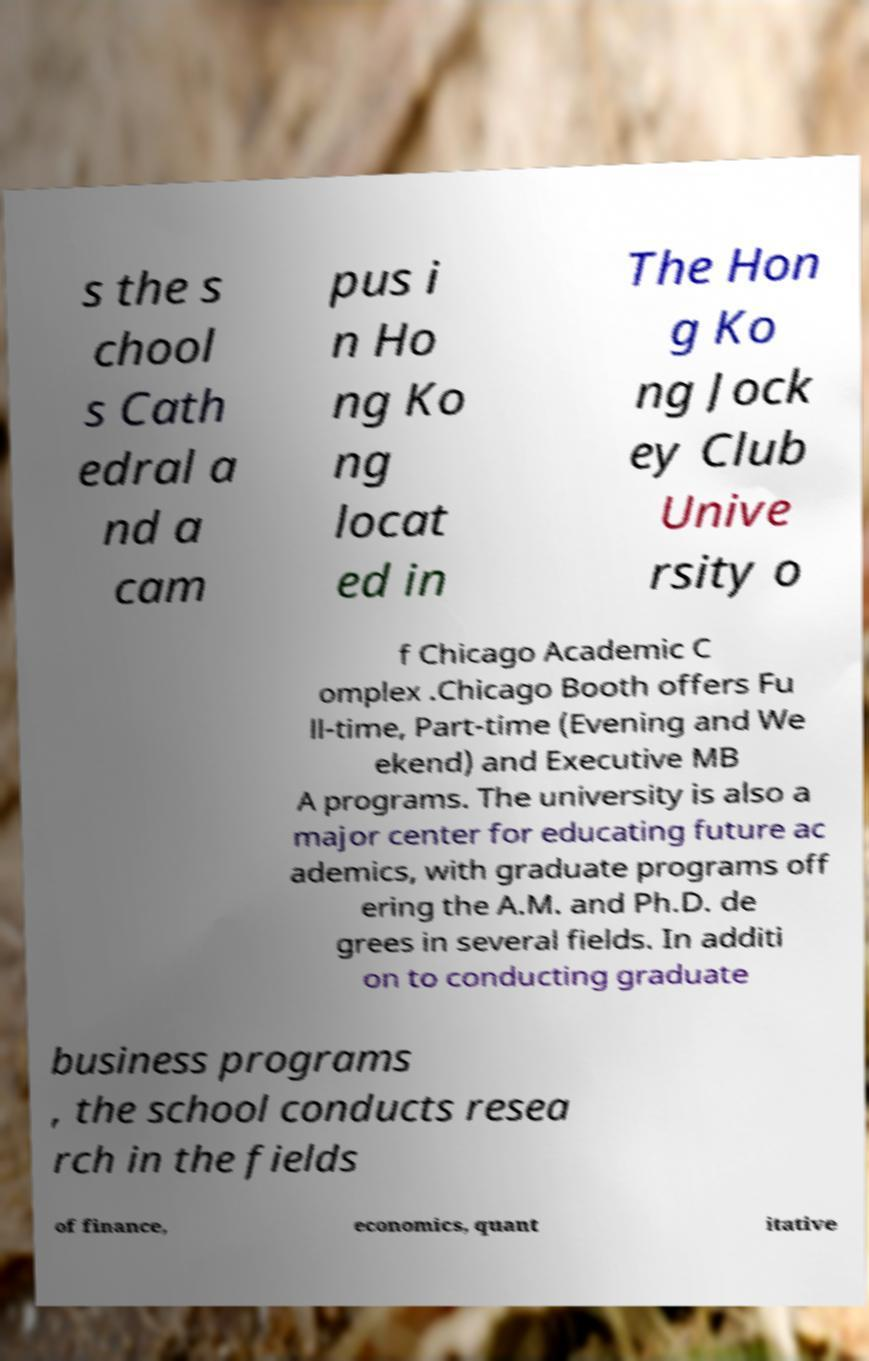Could you assist in decoding the text presented in this image and type it out clearly? s the s chool s Cath edral a nd a cam pus i n Ho ng Ko ng locat ed in The Hon g Ko ng Jock ey Club Unive rsity o f Chicago Academic C omplex .Chicago Booth offers Fu ll-time, Part-time (Evening and We ekend) and Executive MB A programs. The university is also a major center for educating future ac ademics, with graduate programs off ering the A.M. and Ph.D. de grees in several fields. In additi on to conducting graduate business programs , the school conducts resea rch in the fields of finance, economics, quant itative 